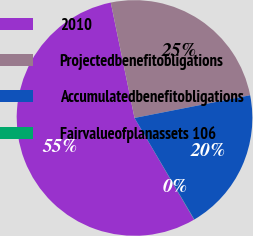Convert chart to OTSL. <chart><loc_0><loc_0><loc_500><loc_500><pie_chart><fcel>2010<fcel>Projectedbenefitobligations<fcel>Accumulatedbenefitobligations<fcel>Fairvalueofplanassets 106<nl><fcel>55.21%<fcel>25.14%<fcel>19.62%<fcel>0.03%<nl></chart> 